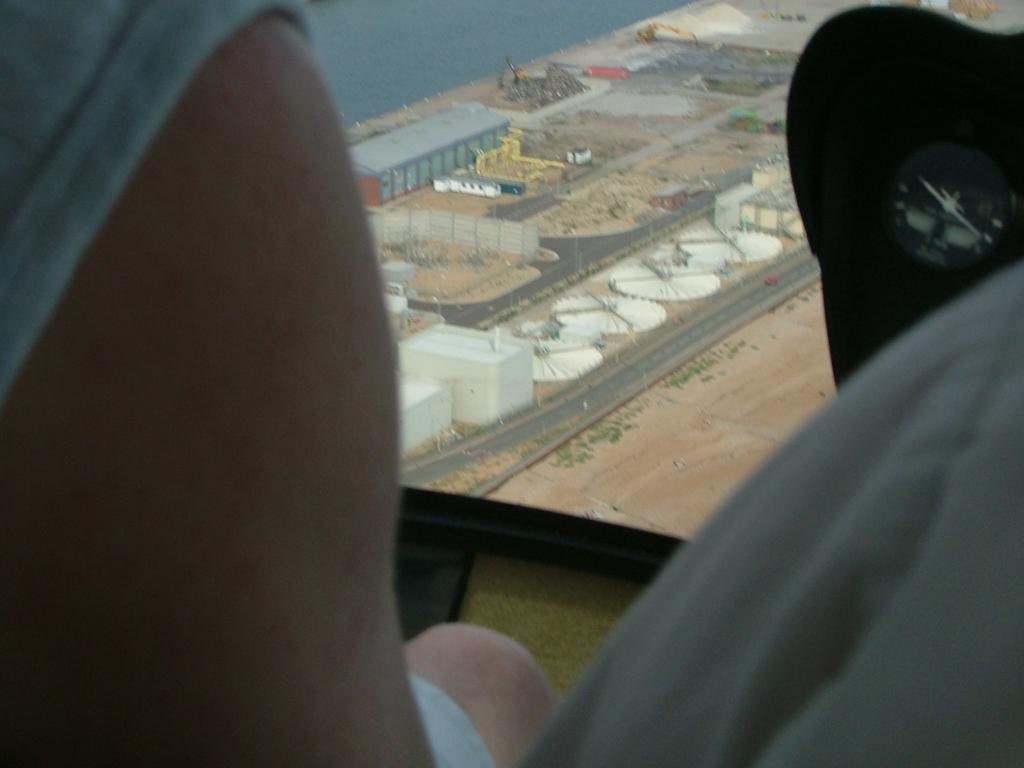What perspective is the image taken from? The image is a top view. Who or what can be seen in the front of the image? There is a man in the front of the image. What type of structures are visible in the background of the image? There are shed houses in the background of the image. What objects are on the ground in the image? There are white big wheels on the ground in the image. What type of skin condition can be seen on the man's face in the image? There is no indication of a skin condition on the man's face in the image. What type of flowers are growing around the shed houses in the image? There are no flowers visible in the image; the image only shows shed houses and a man. 